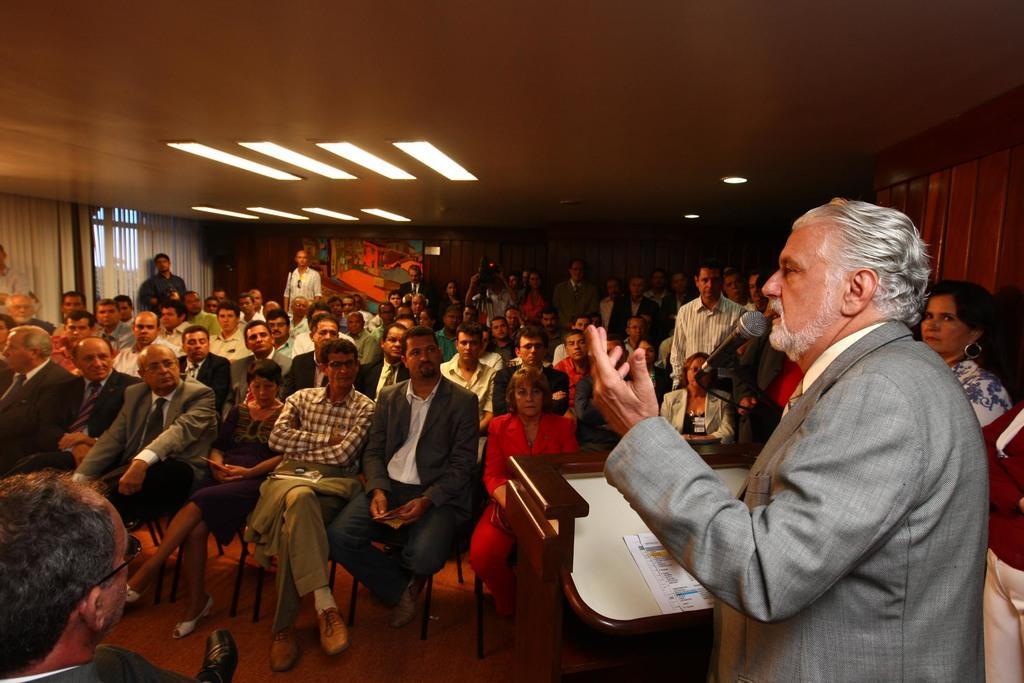In one or two sentences, can you explain what this image depicts? On the right a man is standing at the podium and talking on the mic and there are papers on the podium. In the background there are few persons sitting on the chairs and few are standing and we can also see curtains,windows,lights on the ceiling,a person is holding camera in his hands,boards and at the bottom on the left side there is a person. 